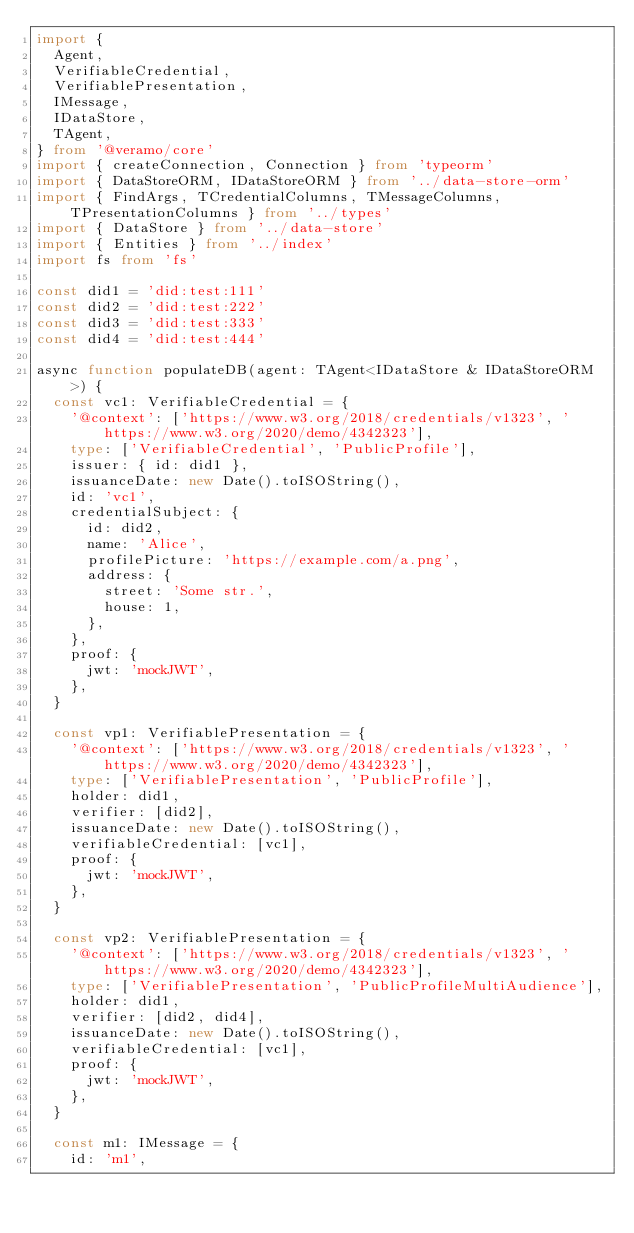<code> <loc_0><loc_0><loc_500><loc_500><_TypeScript_>import {
  Agent,
  VerifiableCredential,
  VerifiablePresentation,
  IMessage,
  IDataStore,
  TAgent,
} from '@veramo/core'
import { createConnection, Connection } from 'typeorm'
import { DataStoreORM, IDataStoreORM } from '../data-store-orm'
import { FindArgs, TCredentialColumns, TMessageColumns, TPresentationColumns } from '../types'
import { DataStore } from '../data-store'
import { Entities } from '../index'
import fs from 'fs'

const did1 = 'did:test:111'
const did2 = 'did:test:222'
const did3 = 'did:test:333'
const did4 = 'did:test:444'

async function populateDB(agent: TAgent<IDataStore & IDataStoreORM>) {
  const vc1: VerifiableCredential = {
    '@context': ['https://www.w3.org/2018/credentials/v1323', 'https://www.w3.org/2020/demo/4342323'],
    type: ['VerifiableCredential', 'PublicProfile'],
    issuer: { id: did1 },
    issuanceDate: new Date().toISOString(),
    id: 'vc1',
    credentialSubject: {
      id: did2,
      name: 'Alice',
      profilePicture: 'https://example.com/a.png',
      address: {
        street: 'Some str.',
        house: 1,
      },
    },
    proof: {
      jwt: 'mockJWT',
    },
  }

  const vp1: VerifiablePresentation = {
    '@context': ['https://www.w3.org/2018/credentials/v1323', 'https://www.w3.org/2020/demo/4342323'],
    type: ['VerifiablePresentation', 'PublicProfile'],
    holder: did1,
    verifier: [did2],
    issuanceDate: new Date().toISOString(),
    verifiableCredential: [vc1],
    proof: {
      jwt: 'mockJWT',
    },
  }

  const vp2: VerifiablePresentation = {
    '@context': ['https://www.w3.org/2018/credentials/v1323', 'https://www.w3.org/2020/demo/4342323'],
    type: ['VerifiablePresentation', 'PublicProfileMultiAudience'],
    holder: did1,
    verifier: [did2, did4],
    issuanceDate: new Date().toISOString(),
    verifiableCredential: [vc1],
    proof: {
      jwt: 'mockJWT',
    },
  }

  const m1: IMessage = {
    id: 'm1',</code> 